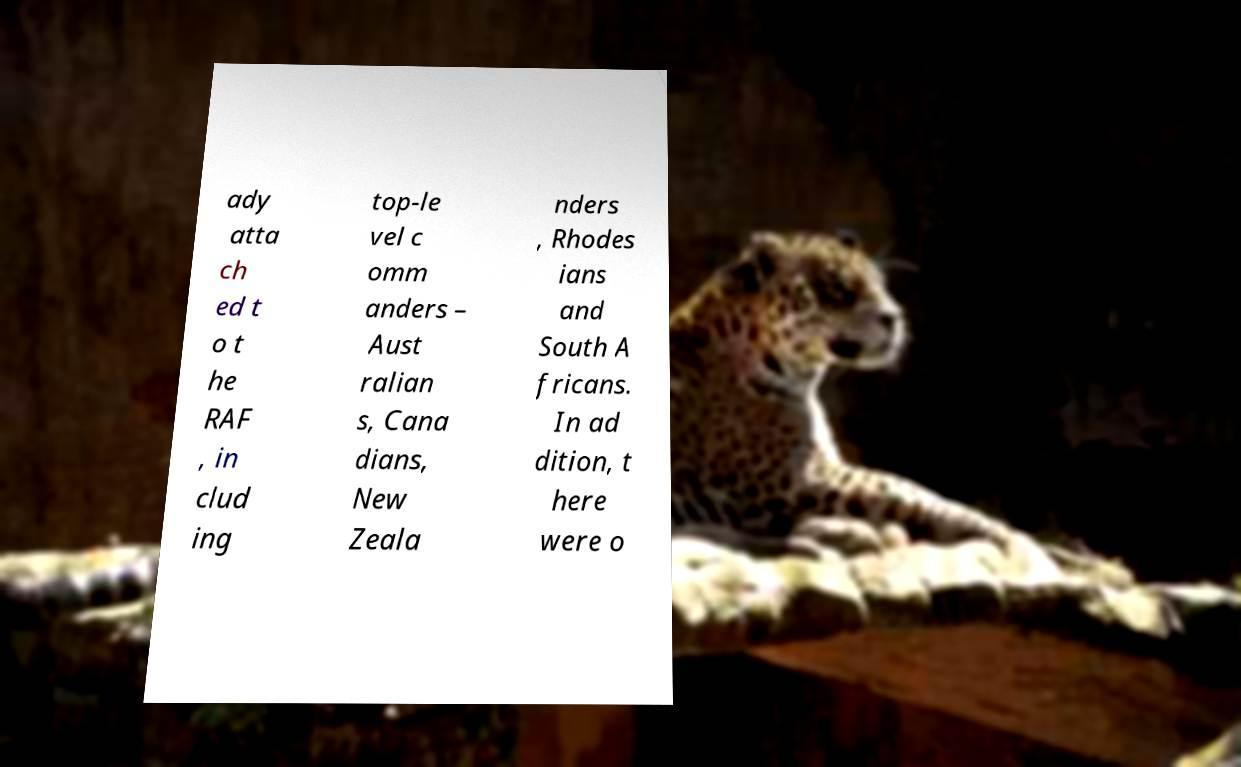There's text embedded in this image that I need extracted. Can you transcribe it verbatim? ady atta ch ed t o t he RAF , in clud ing top-le vel c omm anders – Aust ralian s, Cana dians, New Zeala nders , Rhodes ians and South A fricans. In ad dition, t here were o 